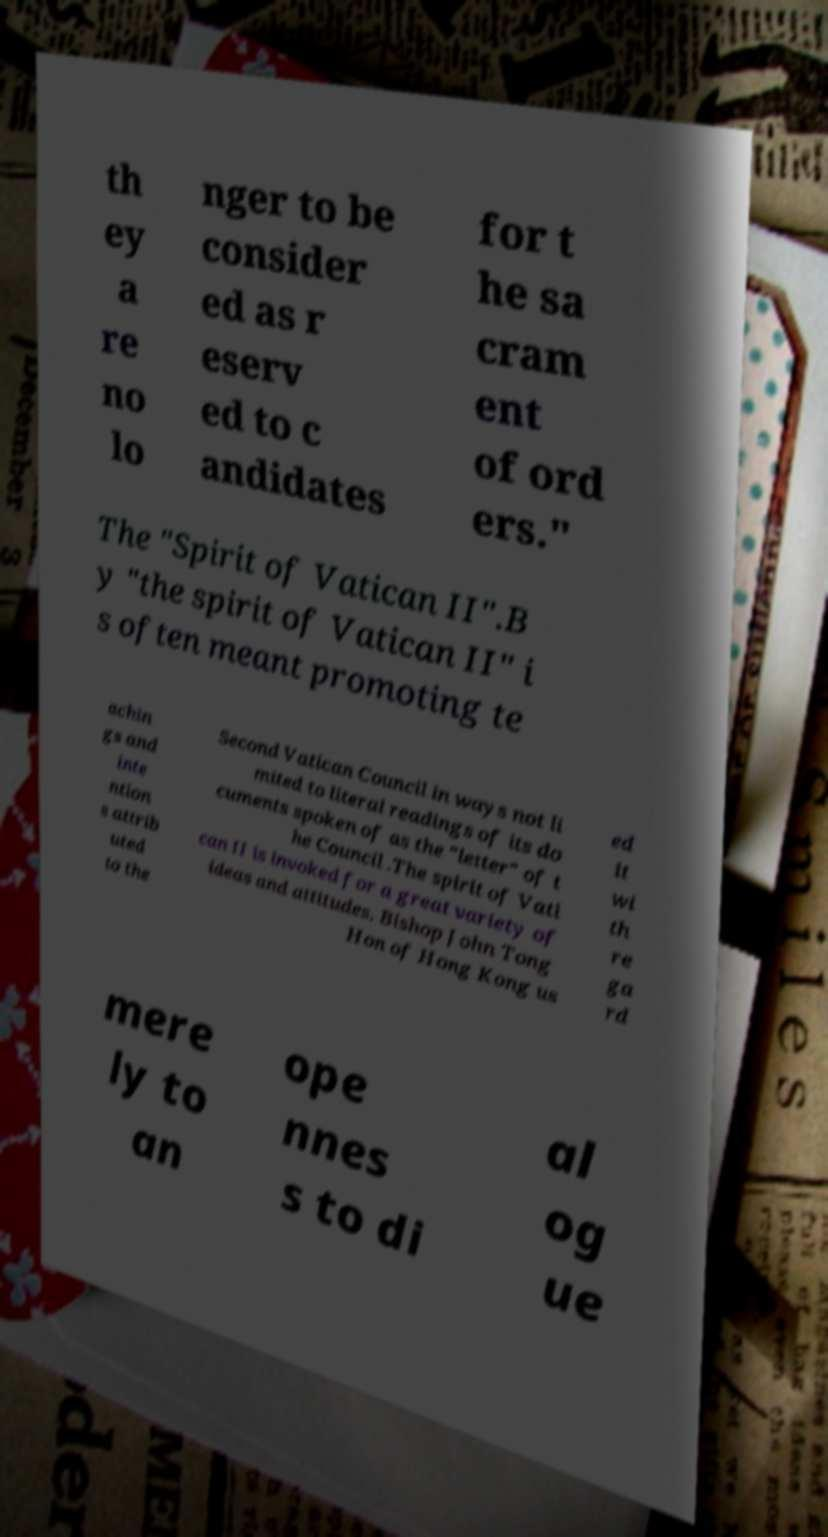I need the written content from this picture converted into text. Can you do that? th ey a re no lo nger to be consider ed as r eserv ed to c andidates for t he sa cram ent of ord ers." The "Spirit of Vatican II".B y "the spirit of Vatican II" i s often meant promoting te achin gs and inte ntion s attrib uted to the Second Vatican Council in ways not li mited to literal readings of its do cuments spoken of as the "letter" of t he Council .The spirit of Vati can II is invoked for a great variety of ideas and attitudes. Bishop John Tong Hon of Hong Kong us ed it wi th re ga rd mere ly to an ope nnes s to di al og ue 